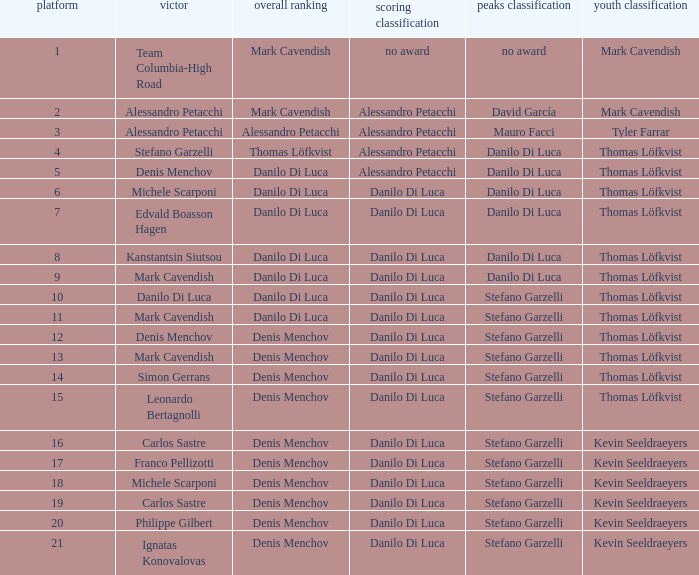When danilo di luca is the winner who is the general classification?  Danilo Di Luca. 